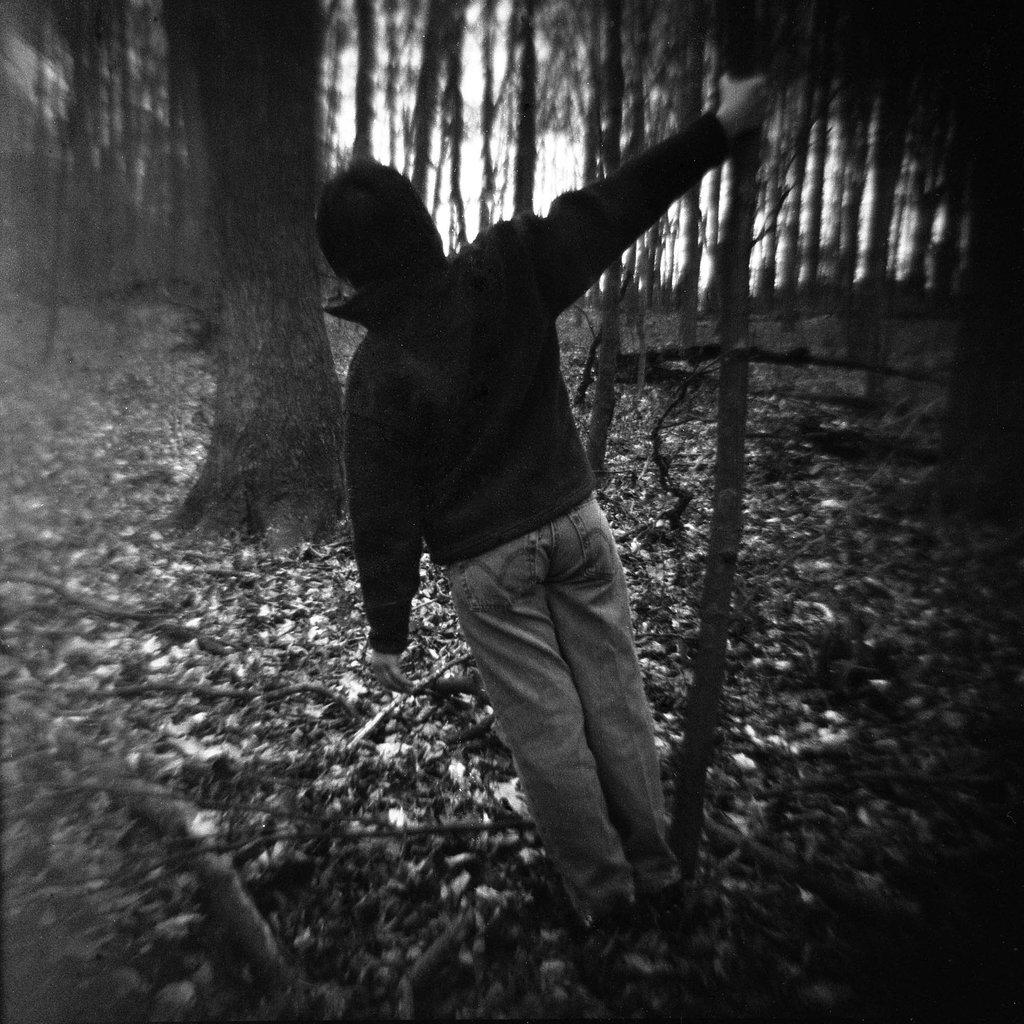What is the main subject of the image? There is a human in the image. What is the human doing in the image? The human is holding a tree bark with their hand. What type of natural environment is depicted in the image? There are trees and leaves on the ground visible in the image. What type of tramp can be seen jumping in the image? There is no tramp present in the image, and therefore no such activity can be observed. Can you tell me how many slaves are depicted in the image? There is no mention of slaves in the image, and therefore no such depiction can be observed. 